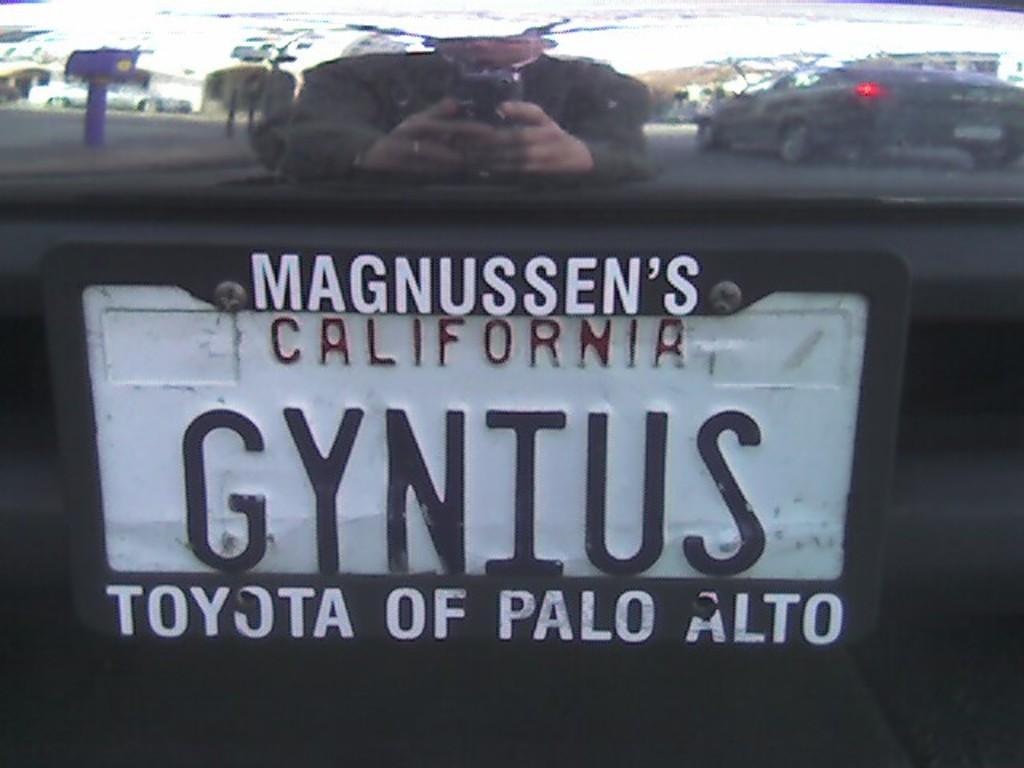How would you summarize this image in a sentence or two? In this picture I can see the car number plate. In the car reflection I can see the man who is holding a mobile phone, road, vehicles, poles, street lights, trees, buildings and other objects. 